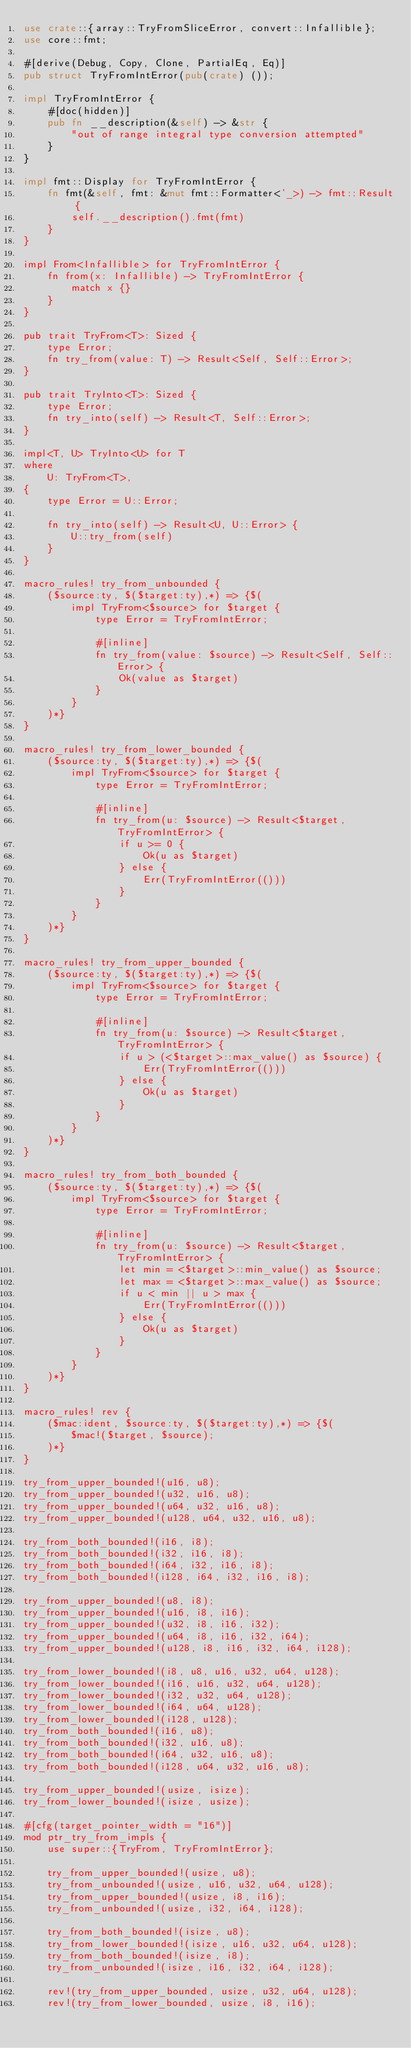Convert code to text. <code><loc_0><loc_0><loc_500><loc_500><_Rust_>use crate::{array::TryFromSliceError, convert::Infallible};
use core::fmt;

#[derive(Debug, Copy, Clone, PartialEq, Eq)]
pub struct TryFromIntError(pub(crate) ());

impl TryFromIntError {
    #[doc(hidden)]
    pub fn __description(&self) -> &str {
        "out of range integral type conversion attempted"
    }
}

impl fmt::Display for TryFromIntError {
    fn fmt(&self, fmt: &mut fmt::Formatter<'_>) -> fmt::Result {
        self.__description().fmt(fmt)
    }
}

impl From<Infallible> for TryFromIntError {
    fn from(x: Infallible) -> TryFromIntError {
        match x {}
    }
}

pub trait TryFrom<T>: Sized {
    type Error;
    fn try_from(value: T) -> Result<Self, Self::Error>;
}

pub trait TryInto<T>: Sized {
    type Error;
    fn try_into(self) -> Result<T, Self::Error>;
}

impl<T, U> TryInto<U> for T
where
    U: TryFrom<T>,
{
    type Error = U::Error;

    fn try_into(self) -> Result<U, U::Error> {
        U::try_from(self)
    }
}

macro_rules! try_from_unbounded {
    ($source:ty, $($target:ty),*) => {$(
        impl TryFrom<$source> for $target {
            type Error = TryFromIntError;

            #[inline]
            fn try_from(value: $source) -> Result<Self, Self::Error> {
                Ok(value as $target)
            }
        }
    )*}
}

macro_rules! try_from_lower_bounded {
    ($source:ty, $($target:ty),*) => {$(
        impl TryFrom<$source> for $target {
            type Error = TryFromIntError;

            #[inline]
            fn try_from(u: $source) -> Result<$target, TryFromIntError> {
                if u >= 0 {
                    Ok(u as $target)
                } else {
                    Err(TryFromIntError(()))
                }
            }
        }
    )*}
}

macro_rules! try_from_upper_bounded {
    ($source:ty, $($target:ty),*) => {$(
        impl TryFrom<$source> for $target {
            type Error = TryFromIntError;

            #[inline]
            fn try_from(u: $source) -> Result<$target, TryFromIntError> {
                if u > (<$target>::max_value() as $source) {
                    Err(TryFromIntError(()))
                } else {
                    Ok(u as $target)
                }
            }
        }
    )*}
}

macro_rules! try_from_both_bounded {
    ($source:ty, $($target:ty),*) => {$(
        impl TryFrom<$source> for $target {
            type Error = TryFromIntError;

            #[inline]
            fn try_from(u: $source) -> Result<$target, TryFromIntError> {
                let min = <$target>::min_value() as $source;
                let max = <$target>::max_value() as $source;
                if u < min || u > max {
                    Err(TryFromIntError(()))
                } else {
                    Ok(u as $target)
                }
            }
        }
    )*}
}

macro_rules! rev {
    ($mac:ident, $source:ty, $($target:ty),*) => {$(
        $mac!($target, $source);
    )*}
}

try_from_upper_bounded!(u16, u8);
try_from_upper_bounded!(u32, u16, u8);
try_from_upper_bounded!(u64, u32, u16, u8);
try_from_upper_bounded!(u128, u64, u32, u16, u8);

try_from_both_bounded!(i16, i8);
try_from_both_bounded!(i32, i16, i8);
try_from_both_bounded!(i64, i32, i16, i8);
try_from_both_bounded!(i128, i64, i32, i16, i8);

try_from_upper_bounded!(u8, i8);
try_from_upper_bounded!(u16, i8, i16);
try_from_upper_bounded!(u32, i8, i16, i32);
try_from_upper_bounded!(u64, i8, i16, i32, i64);
try_from_upper_bounded!(u128, i8, i16, i32, i64, i128);

try_from_lower_bounded!(i8, u8, u16, u32, u64, u128);
try_from_lower_bounded!(i16, u16, u32, u64, u128);
try_from_lower_bounded!(i32, u32, u64, u128);
try_from_lower_bounded!(i64, u64, u128);
try_from_lower_bounded!(i128, u128);
try_from_both_bounded!(i16, u8);
try_from_both_bounded!(i32, u16, u8);
try_from_both_bounded!(i64, u32, u16, u8);
try_from_both_bounded!(i128, u64, u32, u16, u8);

try_from_upper_bounded!(usize, isize);
try_from_lower_bounded!(isize, usize);

#[cfg(target_pointer_width = "16")]
mod ptr_try_from_impls {
    use super::{TryFrom, TryFromIntError};

    try_from_upper_bounded!(usize, u8);
    try_from_unbounded!(usize, u16, u32, u64, u128);
    try_from_upper_bounded!(usize, i8, i16);
    try_from_unbounded!(usize, i32, i64, i128);

    try_from_both_bounded!(isize, u8);
    try_from_lower_bounded!(isize, u16, u32, u64, u128);
    try_from_both_bounded!(isize, i8);
    try_from_unbounded!(isize, i16, i32, i64, i128);

    rev!(try_from_upper_bounded, usize, u32, u64, u128);
    rev!(try_from_lower_bounded, usize, i8, i16);</code> 